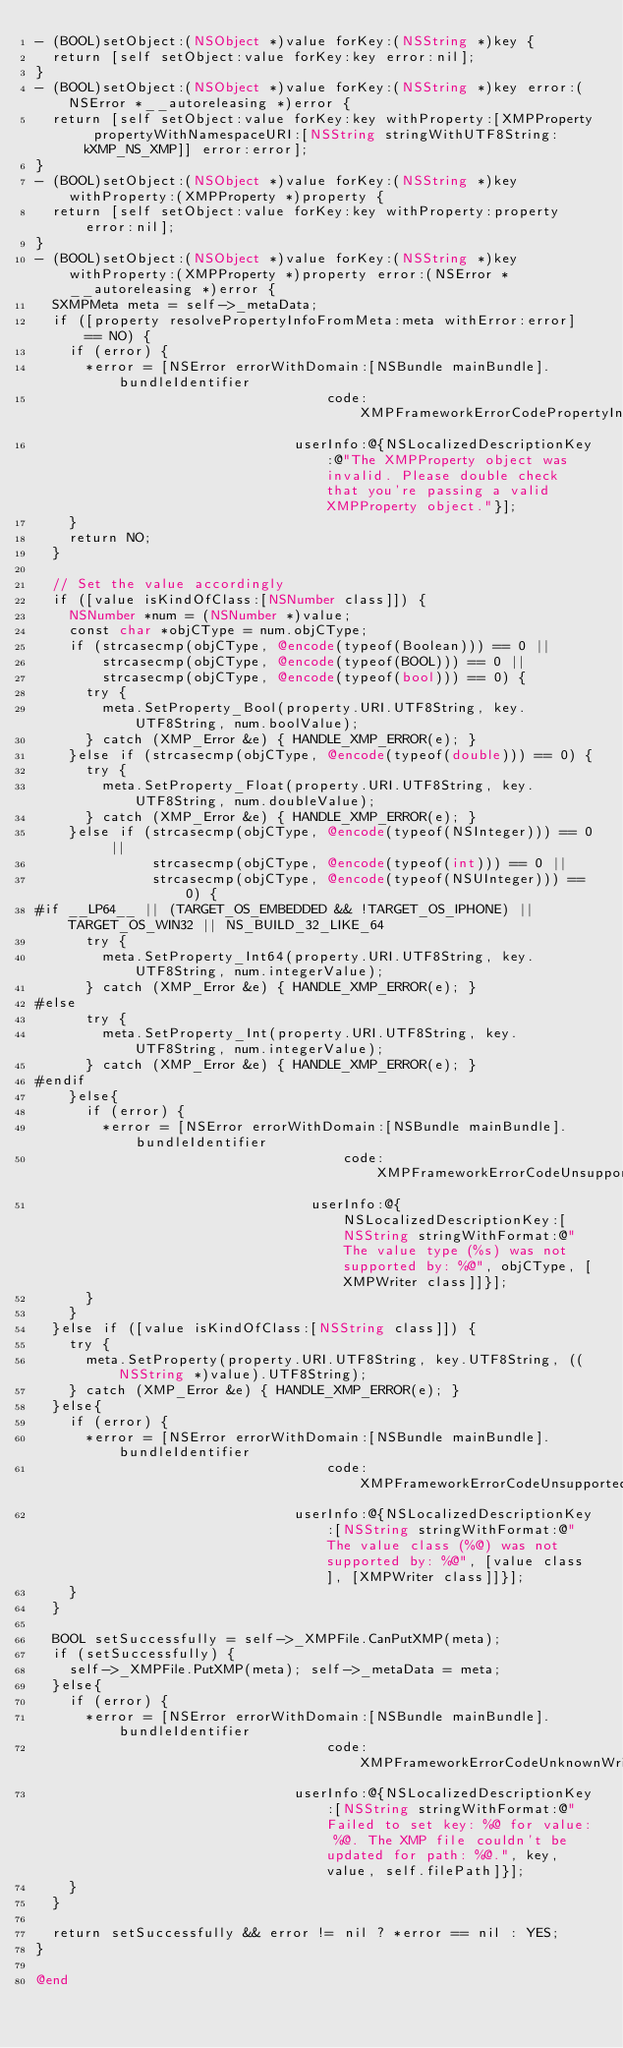Convert code to text. <code><loc_0><loc_0><loc_500><loc_500><_ObjectiveC_>- (BOOL)setObject:(NSObject *)value forKey:(NSString *)key {
  return [self setObject:value forKey:key error:nil];
}
- (BOOL)setObject:(NSObject *)value forKey:(NSString *)key error:(NSError *__autoreleasing *)error {
  return [self setObject:value forKey:key withProperty:[XMPProperty propertyWithNamespaceURI:[NSString stringWithUTF8String:kXMP_NS_XMP]] error:error];
}
- (BOOL)setObject:(NSObject *)value forKey:(NSString *)key withProperty:(XMPProperty *)property {
  return [self setObject:value forKey:key withProperty:property error:nil];
}
- (BOOL)setObject:(NSObject *)value forKey:(NSString *)key withProperty:(XMPProperty *)property error:(NSError *__autoreleasing *)error {
  SXMPMeta meta = self->_metaData;
  if ([property resolvePropertyInfoFromMeta:meta withError:error] == NO) {
    if (error) {
      *error = [NSError errorWithDomain:[NSBundle mainBundle].bundleIdentifier
                                   code:XMPFrameworkErrorCodePropertyInvalid
                               userInfo:@{NSLocalizedDescriptionKey:@"The XMPProperty object was invalid. Please double check that you're passing a valid XMPProperty object."}];
    }
    return NO;
  }
  
  // Set the value accordingly
  if ([value isKindOfClass:[NSNumber class]]) {
    NSNumber *num = (NSNumber *)value;
    const char *objCType = num.objCType;
    if (strcasecmp(objCType, @encode(typeof(Boolean))) == 0 ||
        strcasecmp(objCType, @encode(typeof(BOOL))) == 0 ||
        strcasecmp(objCType, @encode(typeof(bool))) == 0) {
      try {
        meta.SetProperty_Bool(property.URI.UTF8String, key.UTF8String, num.boolValue);
      } catch (XMP_Error &e) { HANDLE_XMP_ERROR(e); }
    }else if (strcasecmp(objCType, @encode(typeof(double))) == 0) {
      try {
        meta.SetProperty_Float(property.URI.UTF8String, key.UTF8String, num.doubleValue);
      } catch (XMP_Error &e) { HANDLE_XMP_ERROR(e); }
    }else if (strcasecmp(objCType, @encode(typeof(NSInteger))) == 0 ||
              strcasecmp(objCType, @encode(typeof(int))) == 0 ||
              strcasecmp(objCType, @encode(typeof(NSUInteger))) == 0) {
#if __LP64__ || (TARGET_OS_EMBEDDED && !TARGET_OS_IPHONE) || TARGET_OS_WIN32 || NS_BUILD_32_LIKE_64
      try {
        meta.SetProperty_Int64(property.URI.UTF8String, key.UTF8String, num.integerValue);
      } catch (XMP_Error &e) { HANDLE_XMP_ERROR(e); }
#else
      try {
        meta.SetProperty_Int(property.URI.UTF8String, key.UTF8String, num.integerValue);
      } catch (XMP_Error &e) { HANDLE_XMP_ERROR(e); }
#endif
    }else{
      if (error) {
        *error = [NSError errorWithDomain:[NSBundle mainBundle].bundleIdentifier
                                     code:XMPFrameworkErrorCodeUnsupportedPrimitiveType
                                 userInfo:@{NSLocalizedDescriptionKey:[NSString stringWithFormat:@"The value type (%s) was not supported by: %@", objCType, [XMPWriter class]]}];
      }
    }
  }else if ([value isKindOfClass:[NSString class]]) {
    try {
      meta.SetProperty(property.URI.UTF8String, key.UTF8String, ((NSString *)value).UTF8String);
    } catch (XMP_Error &e) { HANDLE_XMP_ERROR(e); }
  }else{
    if (error) {
      *error = [NSError errorWithDomain:[NSBundle mainBundle].bundleIdentifier
                                   code:XMPFrameworkErrorCodeUnsupportedObjectType
                               userInfo:@{NSLocalizedDescriptionKey:[NSString stringWithFormat:@"The value class (%@) was not supported by: %@", [value class], [XMPWriter class]]}];
    }
  }
  
  BOOL setSuccessfully = self->_XMPFile.CanPutXMP(meta);
  if (setSuccessfully) {
    self->_XMPFile.PutXMP(meta); self->_metaData = meta;
  }else{
    if (error) {
      *error = [NSError errorWithDomain:[NSBundle mainBundle].bundleIdentifier
                                   code:XMPFrameworkErrorCodeUnknownWriteError
                               userInfo:@{NSLocalizedDescriptionKey:[NSString stringWithFormat:@"Failed to set key: %@ for value: %@. The XMP file couldn't be updated for path: %@.", key, value, self.filePath]}];
    }
  }
  
  return setSuccessfully && error != nil ? *error == nil : YES;
}

@end
</code> 